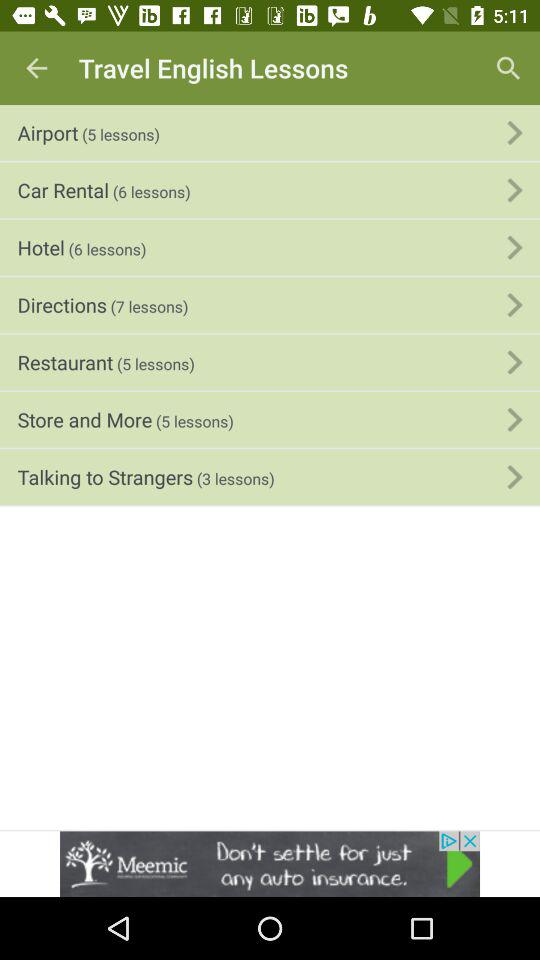Could you describe the design and layout of the lesson menu? Certainly! The lesson menu is displayed on a mobile screen with a green-themed backdrop. Each lesson set is neatly organized with a category name, followed by the number of lessons contained within each category, which are provided in parentheses. The categories listed are 'Airport,' 'Car Rental,' 'Hotel,' 'Directions,' 'Restaurant,' 'Store and More,' and 'Talking to Strangers,' suggesting a comprehensive approach to travel-related English learning. 